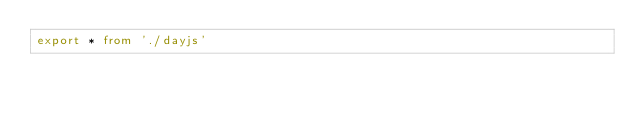Convert code to text. <code><loc_0><loc_0><loc_500><loc_500><_TypeScript_>export * from './dayjs'
</code> 